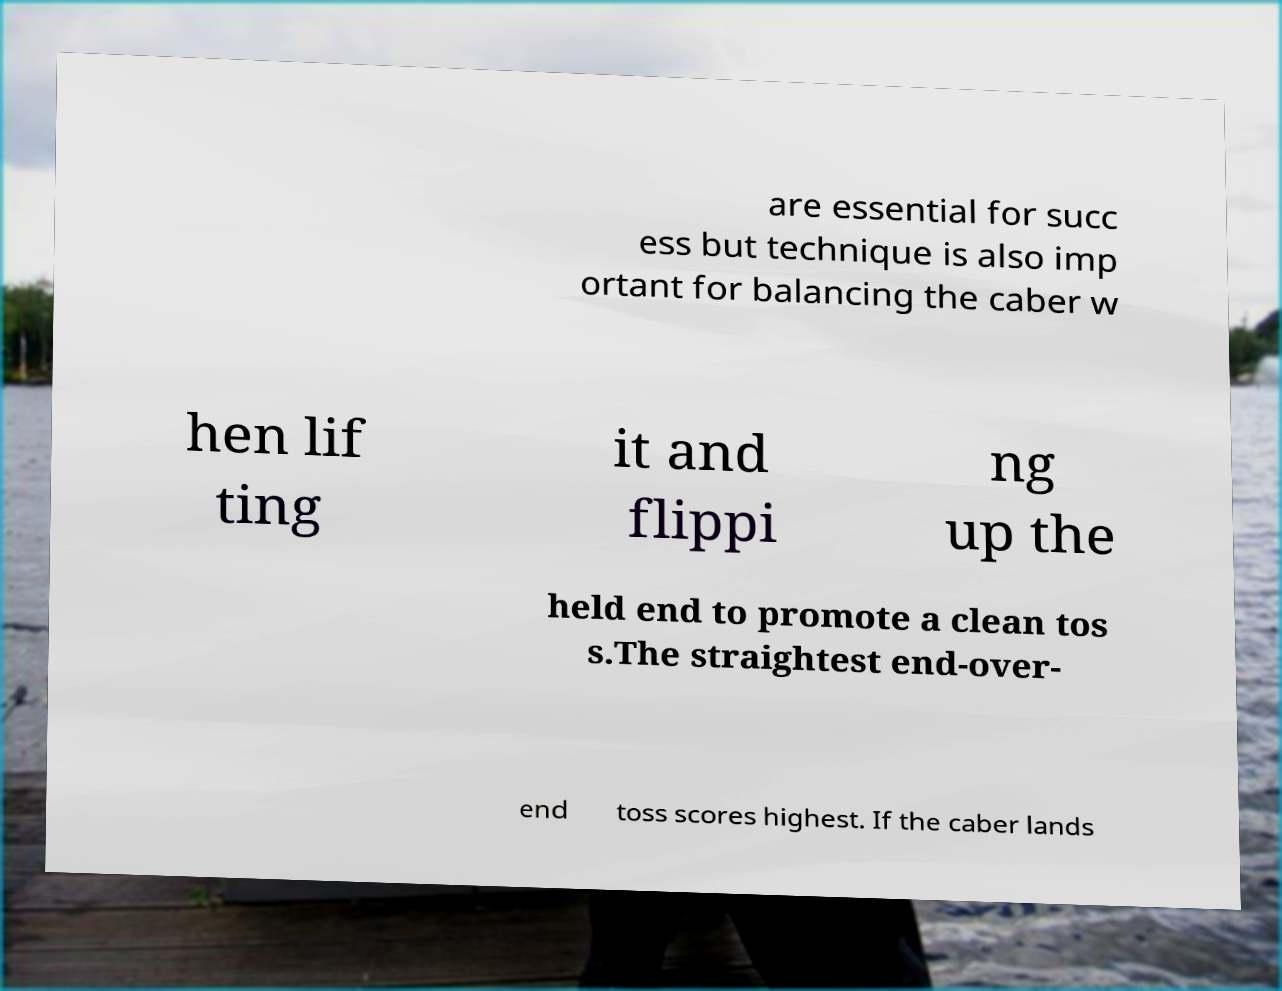Could you assist in decoding the text presented in this image and type it out clearly? are essential for succ ess but technique is also imp ortant for balancing the caber w hen lif ting it and flippi ng up the held end to promote a clean tos s.The straightest end-over- end toss scores highest. If the caber lands 